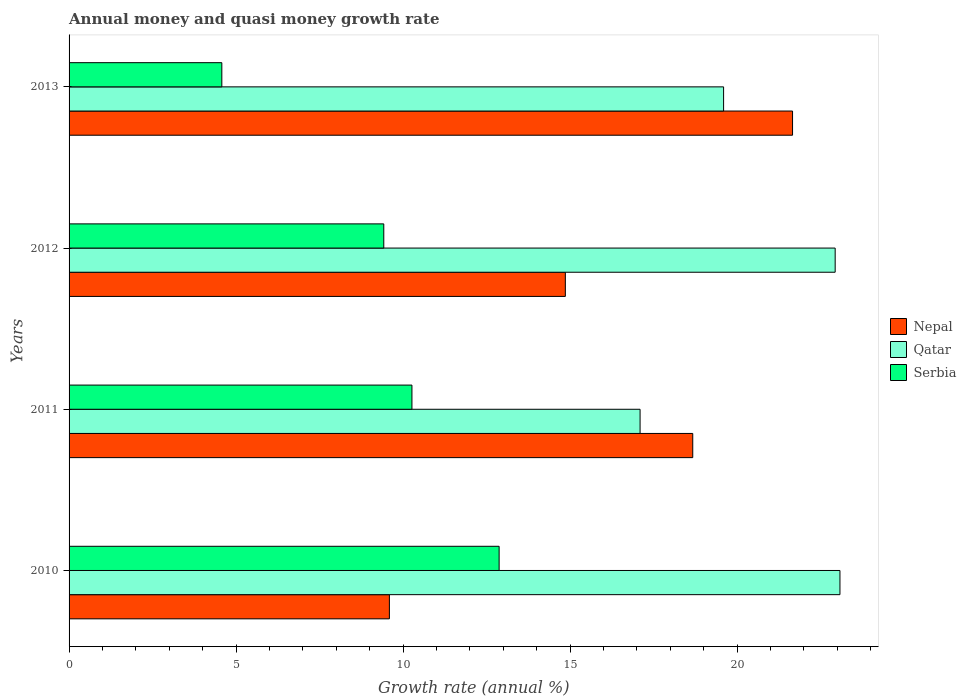How many different coloured bars are there?
Provide a short and direct response. 3. Are the number of bars per tick equal to the number of legend labels?
Provide a short and direct response. Yes. How many bars are there on the 2nd tick from the bottom?
Offer a very short reply. 3. What is the growth rate in Qatar in 2013?
Your answer should be compact. 19.59. Across all years, what is the maximum growth rate in Nepal?
Give a very brief answer. 21.66. Across all years, what is the minimum growth rate in Nepal?
Your response must be concise. 9.59. In which year was the growth rate in Serbia maximum?
Offer a very short reply. 2010. In which year was the growth rate in Qatar minimum?
Give a very brief answer. 2011. What is the total growth rate in Nepal in the graph?
Ensure brevity in your answer.  64.77. What is the difference between the growth rate in Qatar in 2011 and that in 2012?
Your answer should be very brief. -5.84. What is the difference between the growth rate in Nepal in 2013 and the growth rate in Qatar in 2012?
Give a very brief answer. -1.28. What is the average growth rate in Nepal per year?
Your answer should be compact. 16.19. In the year 2013, what is the difference between the growth rate in Serbia and growth rate in Nepal?
Your answer should be very brief. -17.09. In how many years, is the growth rate in Serbia greater than 10 %?
Ensure brevity in your answer.  2. What is the ratio of the growth rate in Serbia in 2012 to that in 2013?
Your response must be concise. 2.06. What is the difference between the highest and the second highest growth rate in Qatar?
Offer a terse response. 0.14. What is the difference between the highest and the lowest growth rate in Serbia?
Your answer should be compact. 8.3. What does the 3rd bar from the top in 2013 represents?
Offer a very short reply. Nepal. What does the 3rd bar from the bottom in 2010 represents?
Your answer should be very brief. Serbia. Is it the case that in every year, the sum of the growth rate in Nepal and growth rate in Serbia is greater than the growth rate in Qatar?
Your answer should be compact. No. How many bars are there?
Keep it short and to the point. 12. What is the difference between two consecutive major ticks on the X-axis?
Provide a short and direct response. 5. Does the graph contain grids?
Offer a very short reply. No. Where does the legend appear in the graph?
Ensure brevity in your answer.  Center right. How are the legend labels stacked?
Your response must be concise. Vertical. What is the title of the graph?
Your answer should be compact. Annual money and quasi money growth rate. Does "Thailand" appear as one of the legend labels in the graph?
Ensure brevity in your answer.  No. What is the label or title of the X-axis?
Provide a short and direct response. Growth rate (annual %). What is the label or title of the Y-axis?
Keep it short and to the point. Years. What is the Growth rate (annual %) of Nepal in 2010?
Your response must be concise. 9.59. What is the Growth rate (annual %) of Qatar in 2010?
Keep it short and to the point. 23.08. What is the Growth rate (annual %) in Serbia in 2010?
Provide a succinct answer. 12.87. What is the Growth rate (annual %) of Nepal in 2011?
Your answer should be very brief. 18.67. What is the Growth rate (annual %) in Qatar in 2011?
Ensure brevity in your answer.  17.09. What is the Growth rate (annual %) in Serbia in 2011?
Offer a very short reply. 10.26. What is the Growth rate (annual %) in Nepal in 2012?
Your answer should be compact. 14.86. What is the Growth rate (annual %) of Qatar in 2012?
Ensure brevity in your answer.  22.93. What is the Growth rate (annual %) of Serbia in 2012?
Your answer should be very brief. 9.42. What is the Growth rate (annual %) of Nepal in 2013?
Give a very brief answer. 21.66. What is the Growth rate (annual %) of Qatar in 2013?
Offer a very short reply. 19.59. What is the Growth rate (annual %) in Serbia in 2013?
Provide a short and direct response. 4.57. Across all years, what is the maximum Growth rate (annual %) in Nepal?
Ensure brevity in your answer.  21.66. Across all years, what is the maximum Growth rate (annual %) in Qatar?
Your response must be concise. 23.08. Across all years, what is the maximum Growth rate (annual %) of Serbia?
Keep it short and to the point. 12.87. Across all years, what is the minimum Growth rate (annual %) of Nepal?
Your answer should be very brief. 9.59. Across all years, what is the minimum Growth rate (annual %) in Qatar?
Give a very brief answer. 17.09. Across all years, what is the minimum Growth rate (annual %) of Serbia?
Your answer should be very brief. 4.57. What is the total Growth rate (annual %) in Nepal in the graph?
Your response must be concise. 64.77. What is the total Growth rate (annual %) in Qatar in the graph?
Provide a short and direct response. 82.7. What is the total Growth rate (annual %) of Serbia in the graph?
Provide a short and direct response. 37.13. What is the difference between the Growth rate (annual %) of Nepal in 2010 and that in 2011?
Your answer should be compact. -9.08. What is the difference between the Growth rate (annual %) of Qatar in 2010 and that in 2011?
Provide a succinct answer. 5.98. What is the difference between the Growth rate (annual %) of Serbia in 2010 and that in 2011?
Ensure brevity in your answer.  2.61. What is the difference between the Growth rate (annual %) of Nepal in 2010 and that in 2012?
Keep it short and to the point. -5.27. What is the difference between the Growth rate (annual %) in Qatar in 2010 and that in 2012?
Provide a short and direct response. 0.14. What is the difference between the Growth rate (annual %) in Serbia in 2010 and that in 2012?
Your response must be concise. 3.45. What is the difference between the Growth rate (annual %) in Nepal in 2010 and that in 2013?
Give a very brief answer. -12.07. What is the difference between the Growth rate (annual %) in Qatar in 2010 and that in 2013?
Ensure brevity in your answer.  3.48. What is the difference between the Growth rate (annual %) of Serbia in 2010 and that in 2013?
Provide a succinct answer. 8.3. What is the difference between the Growth rate (annual %) of Nepal in 2011 and that in 2012?
Provide a short and direct response. 3.81. What is the difference between the Growth rate (annual %) of Qatar in 2011 and that in 2012?
Your response must be concise. -5.84. What is the difference between the Growth rate (annual %) in Serbia in 2011 and that in 2012?
Make the answer very short. 0.84. What is the difference between the Growth rate (annual %) of Nepal in 2011 and that in 2013?
Your response must be concise. -2.99. What is the difference between the Growth rate (annual %) of Qatar in 2011 and that in 2013?
Your answer should be compact. -2.5. What is the difference between the Growth rate (annual %) of Serbia in 2011 and that in 2013?
Your answer should be compact. 5.69. What is the difference between the Growth rate (annual %) in Nepal in 2012 and that in 2013?
Make the answer very short. -6.8. What is the difference between the Growth rate (annual %) in Qatar in 2012 and that in 2013?
Offer a very short reply. 3.34. What is the difference between the Growth rate (annual %) in Serbia in 2012 and that in 2013?
Provide a short and direct response. 4.85. What is the difference between the Growth rate (annual %) in Nepal in 2010 and the Growth rate (annual %) in Qatar in 2011?
Provide a succinct answer. -7.5. What is the difference between the Growth rate (annual %) of Nepal in 2010 and the Growth rate (annual %) of Serbia in 2011?
Your answer should be compact. -0.67. What is the difference between the Growth rate (annual %) in Qatar in 2010 and the Growth rate (annual %) in Serbia in 2011?
Give a very brief answer. 12.81. What is the difference between the Growth rate (annual %) in Nepal in 2010 and the Growth rate (annual %) in Qatar in 2012?
Ensure brevity in your answer.  -13.34. What is the difference between the Growth rate (annual %) of Nepal in 2010 and the Growth rate (annual %) of Serbia in 2012?
Offer a very short reply. 0.17. What is the difference between the Growth rate (annual %) in Qatar in 2010 and the Growth rate (annual %) in Serbia in 2012?
Your response must be concise. 13.66. What is the difference between the Growth rate (annual %) in Nepal in 2010 and the Growth rate (annual %) in Qatar in 2013?
Your answer should be very brief. -10. What is the difference between the Growth rate (annual %) of Nepal in 2010 and the Growth rate (annual %) of Serbia in 2013?
Make the answer very short. 5.02. What is the difference between the Growth rate (annual %) in Qatar in 2010 and the Growth rate (annual %) in Serbia in 2013?
Give a very brief answer. 18.5. What is the difference between the Growth rate (annual %) of Nepal in 2011 and the Growth rate (annual %) of Qatar in 2012?
Provide a short and direct response. -4.26. What is the difference between the Growth rate (annual %) of Nepal in 2011 and the Growth rate (annual %) of Serbia in 2012?
Make the answer very short. 9.25. What is the difference between the Growth rate (annual %) in Qatar in 2011 and the Growth rate (annual %) in Serbia in 2012?
Ensure brevity in your answer.  7.67. What is the difference between the Growth rate (annual %) in Nepal in 2011 and the Growth rate (annual %) in Qatar in 2013?
Make the answer very short. -0.92. What is the difference between the Growth rate (annual %) in Nepal in 2011 and the Growth rate (annual %) in Serbia in 2013?
Offer a very short reply. 14.1. What is the difference between the Growth rate (annual %) of Qatar in 2011 and the Growth rate (annual %) of Serbia in 2013?
Your answer should be very brief. 12.52. What is the difference between the Growth rate (annual %) in Nepal in 2012 and the Growth rate (annual %) in Qatar in 2013?
Keep it short and to the point. -4.74. What is the difference between the Growth rate (annual %) in Nepal in 2012 and the Growth rate (annual %) in Serbia in 2013?
Provide a short and direct response. 10.28. What is the difference between the Growth rate (annual %) in Qatar in 2012 and the Growth rate (annual %) in Serbia in 2013?
Ensure brevity in your answer.  18.36. What is the average Growth rate (annual %) in Nepal per year?
Provide a succinct answer. 16.19. What is the average Growth rate (annual %) in Qatar per year?
Your answer should be very brief. 20.67. What is the average Growth rate (annual %) of Serbia per year?
Provide a succinct answer. 9.28. In the year 2010, what is the difference between the Growth rate (annual %) in Nepal and Growth rate (annual %) in Qatar?
Provide a short and direct response. -13.49. In the year 2010, what is the difference between the Growth rate (annual %) of Nepal and Growth rate (annual %) of Serbia?
Your response must be concise. -3.29. In the year 2010, what is the difference between the Growth rate (annual %) of Qatar and Growth rate (annual %) of Serbia?
Give a very brief answer. 10.2. In the year 2011, what is the difference between the Growth rate (annual %) in Nepal and Growth rate (annual %) in Qatar?
Your answer should be very brief. 1.58. In the year 2011, what is the difference between the Growth rate (annual %) in Nepal and Growth rate (annual %) in Serbia?
Offer a terse response. 8.41. In the year 2011, what is the difference between the Growth rate (annual %) in Qatar and Growth rate (annual %) in Serbia?
Your answer should be compact. 6.83. In the year 2012, what is the difference between the Growth rate (annual %) in Nepal and Growth rate (annual %) in Qatar?
Your answer should be very brief. -8.08. In the year 2012, what is the difference between the Growth rate (annual %) in Nepal and Growth rate (annual %) in Serbia?
Offer a very short reply. 5.44. In the year 2012, what is the difference between the Growth rate (annual %) in Qatar and Growth rate (annual %) in Serbia?
Provide a succinct answer. 13.51. In the year 2013, what is the difference between the Growth rate (annual %) of Nepal and Growth rate (annual %) of Qatar?
Keep it short and to the point. 2.06. In the year 2013, what is the difference between the Growth rate (annual %) of Nepal and Growth rate (annual %) of Serbia?
Provide a succinct answer. 17.09. In the year 2013, what is the difference between the Growth rate (annual %) of Qatar and Growth rate (annual %) of Serbia?
Your answer should be compact. 15.02. What is the ratio of the Growth rate (annual %) of Nepal in 2010 to that in 2011?
Your answer should be compact. 0.51. What is the ratio of the Growth rate (annual %) in Qatar in 2010 to that in 2011?
Your answer should be compact. 1.35. What is the ratio of the Growth rate (annual %) in Serbia in 2010 to that in 2011?
Give a very brief answer. 1.25. What is the ratio of the Growth rate (annual %) in Nepal in 2010 to that in 2012?
Make the answer very short. 0.65. What is the ratio of the Growth rate (annual %) of Serbia in 2010 to that in 2012?
Give a very brief answer. 1.37. What is the ratio of the Growth rate (annual %) of Nepal in 2010 to that in 2013?
Make the answer very short. 0.44. What is the ratio of the Growth rate (annual %) of Qatar in 2010 to that in 2013?
Ensure brevity in your answer.  1.18. What is the ratio of the Growth rate (annual %) of Serbia in 2010 to that in 2013?
Offer a very short reply. 2.82. What is the ratio of the Growth rate (annual %) of Nepal in 2011 to that in 2012?
Provide a succinct answer. 1.26. What is the ratio of the Growth rate (annual %) of Qatar in 2011 to that in 2012?
Your answer should be very brief. 0.75. What is the ratio of the Growth rate (annual %) of Serbia in 2011 to that in 2012?
Make the answer very short. 1.09. What is the ratio of the Growth rate (annual %) in Nepal in 2011 to that in 2013?
Make the answer very short. 0.86. What is the ratio of the Growth rate (annual %) in Qatar in 2011 to that in 2013?
Provide a succinct answer. 0.87. What is the ratio of the Growth rate (annual %) of Serbia in 2011 to that in 2013?
Your answer should be very brief. 2.24. What is the ratio of the Growth rate (annual %) of Nepal in 2012 to that in 2013?
Your answer should be very brief. 0.69. What is the ratio of the Growth rate (annual %) of Qatar in 2012 to that in 2013?
Keep it short and to the point. 1.17. What is the ratio of the Growth rate (annual %) in Serbia in 2012 to that in 2013?
Your answer should be compact. 2.06. What is the difference between the highest and the second highest Growth rate (annual %) of Nepal?
Give a very brief answer. 2.99. What is the difference between the highest and the second highest Growth rate (annual %) of Qatar?
Your answer should be very brief. 0.14. What is the difference between the highest and the second highest Growth rate (annual %) in Serbia?
Your answer should be very brief. 2.61. What is the difference between the highest and the lowest Growth rate (annual %) in Nepal?
Your response must be concise. 12.07. What is the difference between the highest and the lowest Growth rate (annual %) in Qatar?
Make the answer very short. 5.98. What is the difference between the highest and the lowest Growth rate (annual %) in Serbia?
Keep it short and to the point. 8.3. 